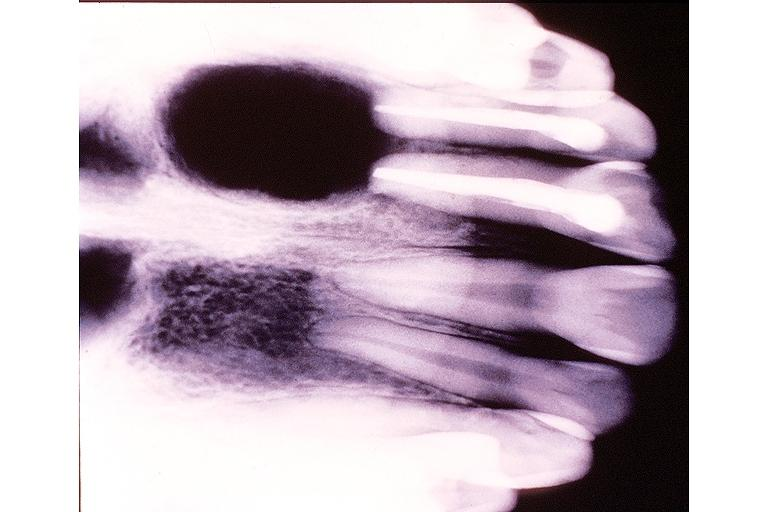s oral present?
Answer the question using a single word or phrase. Yes 